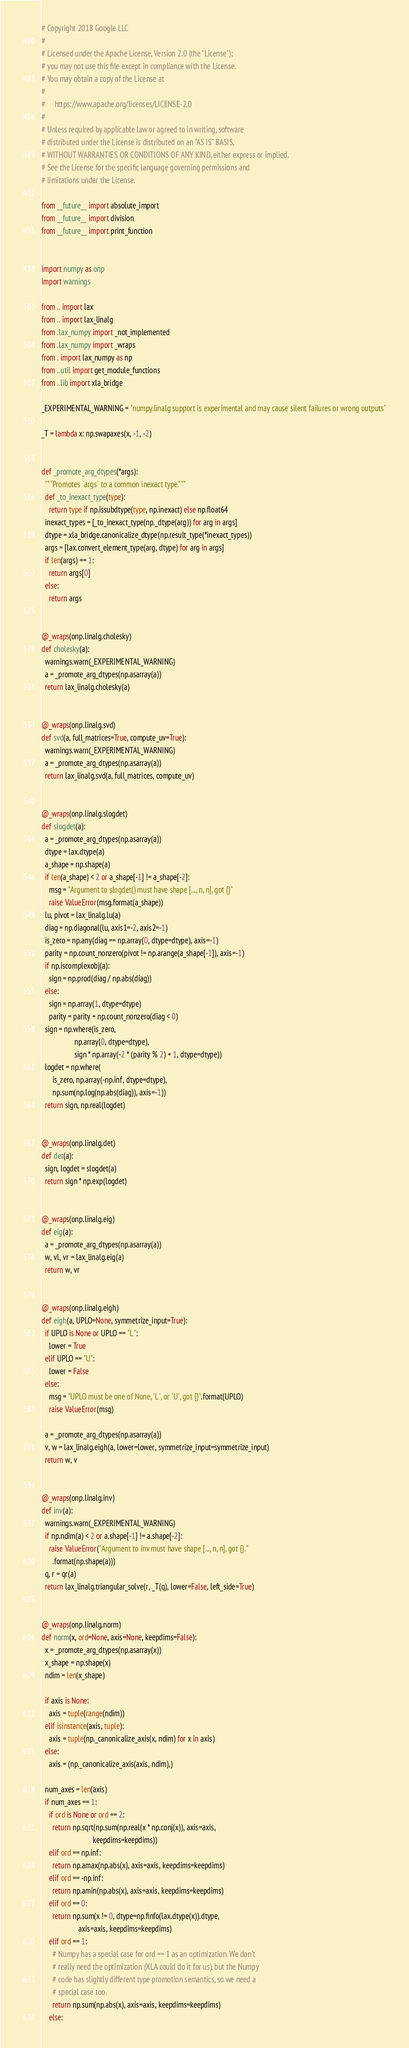Convert code to text. <code><loc_0><loc_0><loc_500><loc_500><_Python_># Copyright 2018 Google LLC
#
# Licensed under the Apache License, Version 2.0 (the "License");
# you may not use this file except in compliance with the License.
# You may obtain a copy of the License at
#
#     https://www.apache.org/licenses/LICENSE-2.0
#
# Unless required by applicable law or agreed to in writing, software
# distributed under the License is distributed on an "AS IS" BASIS,
# WITHOUT WARRANTIES OR CONDITIONS OF ANY KIND, either express or implied.
# See the License for the specific language governing permissions and
# limitations under the License.

from __future__ import absolute_import
from __future__ import division
from __future__ import print_function


import numpy as onp
import warnings

from .. import lax
from .. import lax_linalg
from .lax_numpy import _not_implemented
from .lax_numpy import _wraps
from . import lax_numpy as np
from ..util import get_module_functions
from ..lib import xla_bridge

_EXPERIMENTAL_WARNING = "numpy.linalg support is experimental and may cause silent failures or wrong outputs"

_T = lambda x: np.swapaxes(x, -1, -2)


def _promote_arg_dtypes(*args):
  """Promotes `args` to a common inexact type."""
  def _to_inexact_type(type):
    return type if np.issubdtype(type, np.inexact) else np.float64
  inexact_types = [_to_inexact_type(np._dtype(arg)) for arg in args]
  dtype = xla_bridge.canonicalize_dtype(np.result_type(*inexact_types))
  args = [lax.convert_element_type(arg, dtype) for arg in args]
  if len(args) == 1:
    return args[0]
  else:
    return args


@_wraps(onp.linalg.cholesky)
def cholesky(a):
  warnings.warn(_EXPERIMENTAL_WARNING)
  a = _promote_arg_dtypes(np.asarray(a))
  return lax_linalg.cholesky(a)


@_wraps(onp.linalg.svd)
def svd(a, full_matrices=True, compute_uv=True):
  warnings.warn(_EXPERIMENTAL_WARNING)
  a = _promote_arg_dtypes(np.asarray(a))
  return lax_linalg.svd(a, full_matrices, compute_uv)


@_wraps(onp.linalg.slogdet)
def slogdet(a):
  a = _promote_arg_dtypes(np.asarray(a))
  dtype = lax.dtype(a)
  a_shape = np.shape(a)
  if len(a_shape) < 2 or a_shape[-1] != a_shape[-2]:
    msg = "Argument to slogdet() must have shape [..., n, n], got {}"
    raise ValueError(msg.format(a_shape))
  lu, pivot = lax_linalg.lu(a)
  diag = np.diagonal(lu, axis1=-2, axis2=-1)
  is_zero = np.any(diag == np.array(0, dtype=dtype), axis=-1)
  parity = np.count_nonzero(pivot != np.arange(a_shape[-1]), axis=-1)
  if np.iscomplexobj(a):
    sign = np.prod(diag / np.abs(diag))
  else:
    sign = np.array(1, dtype=dtype)
    parity = parity + np.count_nonzero(diag < 0)
  sign = np.where(is_zero,
                  np.array(0, dtype=dtype),
                  sign * np.array(-2 * (parity % 2) + 1, dtype=dtype))
  logdet = np.where(
      is_zero, np.array(-np.inf, dtype=dtype),
      np.sum(np.log(np.abs(diag)), axis=-1))
  return sign, np.real(logdet)


@_wraps(onp.linalg.det)
def det(a):
  sign, logdet = slogdet(a)
  return sign * np.exp(logdet)


@_wraps(onp.linalg.eig)
def eig(a):
  a = _promote_arg_dtypes(np.asarray(a))
  w, vl, vr = lax_linalg.eig(a)
  return w, vr


@_wraps(onp.linalg.eigh)
def eigh(a, UPLO=None, symmetrize_input=True):
  if UPLO is None or UPLO == "L":
    lower = True
  elif UPLO == "U":
    lower = False
  else:
    msg = "UPLO must be one of None, 'L', or 'U', got {}".format(UPLO)
    raise ValueError(msg)

  a = _promote_arg_dtypes(np.asarray(a))
  v, w = lax_linalg.eigh(a, lower=lower, symmetrize_input=symmetrize_input)
  return w, v


@_wraps(onp.linalg.inv)
def inv(a):
  warnings.warn(_EXPERIMENTAL_WARNING)
  if np.ndim(a) < 2 or a.shape[-1] != a.shape[-2]:
    raise ValueError("Argument to inv must have shape [..., n, n], got {}."
      .format(np.shape(a)))
  q, r = qr(a)
  return lax_linalg.triangular_solve(r, _T(q), lower=False, left_side=True)


@_wraps(onp.linalg.norm)
def norm(x, ord=None, axis=None, keepdims=False):
  x = _promote_arg_dtypes(np.asarray(x))
  x_shape = np.shape(x)
  ndim = len(x_shape)

  if axis is None:
    axis = tuple(range(ndim))
  elif isinstance(axis, tuple):
    axis = tuple(np._canonicalize_axis(x, ndim) for x in axis)
  else:
    axis = (np._canonicalize_axis(axis, ndim),)

  num_axes = len(axis)
  if num_axes == 1:
    if ord is None or ord == 2:
      return np.sqrt(np.sum(np.real(x * np.conj(x)), axis=axis,
                            keepdims=keepdims))
    elif ord == np.inf:
      return np.amax(np.abs(x), axis=axis, keepdims=keepdims)
    elif ord == -np.inf:
      return np.amin(np.abs(x), axis=axis, keepdims=keepdims)
    elif ord == 0:
      return np.sum(x != 0, dtype=np.finfo(lax.dtype(x)).dtype,
                    axis=axis, keepdims=keepdims)
    elif ord == 1:
      # Numpy has a special case for ord == 1 as an optimization. We don't
      # really need the optimization (XLA could do it for us), but the Numpy
      # code has slightly different type promotion semantics, so we need a
      # special case too.
      return np.sum(np.abs(x), axis=axis, keepdims=keepdims)
    else:</code> 